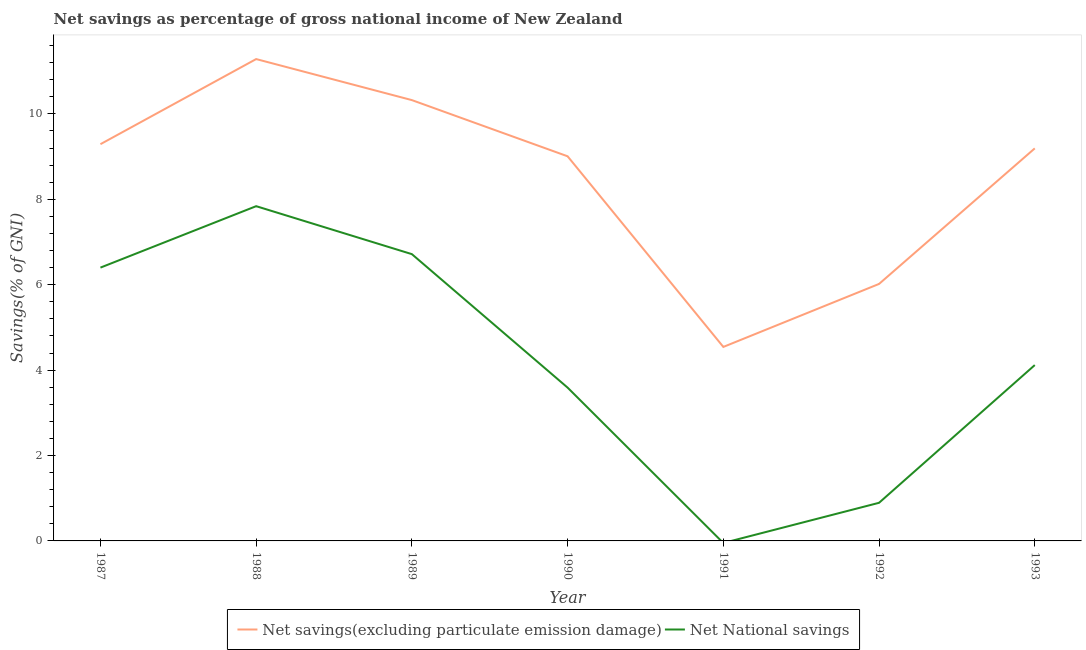Does the line corresponding to net savings(excluding particulate emission damage) intersect with the line corresponding to net national savings?
Your answer should be compact. No. Is the number of lines equal to the number of legend labels?
Keep it short and to the point. No. What is the net national savings in 1990?
Provide a short and direct response. 3.59. Across all years, what is the maximum net national savings?
Keep it short and to the point. 7.84. Across all years, what is the minimum net savings(excluding particulate emission damage)?
Make the answer very short. 4.54. In which year was the net national savings maximum?
Your answer should be very brief. 1988. What is the total net savings(excluding particulate emission damage) in the graph?
Offer a terse response. 59.66. What is the difference between the net national savings in 1987 and that in 1988?
Give a very brief answer. -1.44. What is the difference between the net savings(excluding particulate emission damage) in 1990 and the net national savings in 1992?
Offer a terse response. 8.11. What is the average net savings(excluding particulate emission damage) per year?
Make the answer very short. 8.52. In the year 1990, what is the difference between the net savings(excluding particulate emission damage) and net national savings?
Offer a very short reply. 5.42. What is the ratio of the net national savings in 1987 to that in 1993?
Provide a short and direct response. 1.55. Is the net savings(excluding particulate emission damage) in 1987 less than that in 1990?
Offer a very short reply. No. What is the difference between the highest and the second highest net national savings?
Provide a succinct answer. 1.12. What is the difference between the highest and the lowest net national savings?
Provide a succinct answer. 7.84. In how many years, is the net savings(excluding particulate emission damage) greater than the average net savings(excluding particulate emission damage) taken over all years?
Provide a succinct answer. 5. Is the net savings(excluding particulate emission damage) strictly greater than the net national savings over the years?
Your answer should be very brief. Yes. Is the net national savings strictly less than the net savings(excluding particulate emission damage) over the years?
Provide a succinct answer. Yes. How many lines are there?
Offer a terse response. 2. Where does the legend appear in the graph?
Make the answer very short. Bottom center. How many legend labels are there?
Your answer should be very brief. 2. How are the legend labels stacked?
Your answer should be very brief. Horizontal. What is the title of the graph?
Your answer should be compact. Net savings as percentage of gross national income of New Zealand. Does "Manufacturing industries and construction" appear as one of the legend labels in the graph?
Offer a terse response. No. What is the label or title of the Y-axis?
Keep it short and to the point. Savings(% of GNI). What is the Savings(% of GNI) in Net savings(excluding particulate emission damage) in 1987?
Provide a short and direct response. 9.29. What is the Savings(% of GNI) in Net National savings in 1987?
Your response must be concise. 6.4. What is the Savings(% of GNI) of Net savings(excluding particulate emission damage) in 1988?
Your answer should be compact. 11.28. What is the Savings(% of GNI) of Net National savings in 1988?
Offer a terse response. 7.84. What is the Savings(% of GNI) in Net savings(excluding particulate emission damage) in 1989?
Ensure brevity in your answer.  10.32. What is the Savings(% of GNI) of Net National savings in 1989?
Provide a short and direct response. 6.72. What is the Savings(% of GNI) in Net savings(excluding particulate emission damage) in 1990?
Offer a terse response. 9.01. What is the Savings(% of GNI) in Net National savings in 1990?
Your response must be concise. 3.59. What is the Savings(% of GNI) in Net savings(excluding particulate emission damage) in 1991?
Your response must be concise. 4.54. What is the Savings(% of GNI) in Net savings(excluding particulate emission damage) in 1992?
Your answer should be compact. 6.02. What is the Savings(% of GNI) of Net National savings in 1992?
Your response must be concise. 0.89. What is the Savings(% of GNI) in Net savings(excluding particulate emission damage) in 1993?
Offer a very short reply. 9.19. What is the Savings(% of GNI) in Net National savings in 1993?
Your response must be concise. 4.12. Across all years, what is the maximum Savings(% of GNI) in Net savings(excluding particulate emission damage)?
Your answer should be very brief. 11.28. Across all years, what is the maximum Savings(% of GNI) of Net National savings?
Make the answer very short. 7.84. Across all years, what is the minimum Savings(% of GNI) of Net savings(excluding particulate emission damage)?
Provide a short and direct response. 4.54. Across all years, what is the minimum Savings(% of GNI) in Net National savings?
Make the answer very short. 0. What is the total Savings(% of GNI) in Net savings(excluding particulate emission damage) in the graph?
Give a very brief answer. 59.66. What is the total Savings(% of GNI) of Net National savings in the graph?
Make the answer very short. 29.56. What is the difference between the Savings(% of GNI) in Net savings(excluding particulate emission damage) in 1987 and that in 1988?
Give a very brief answer. -1.99. What is the difference between the Savings(% of GNI) of Net National savings in 1987 and that in 1988?
Your response must be concise. -1.44. What is the difference between the Savings(% of GNI) in Net savings(excluding particulate emission damage) in 1987 and that in 1989?
Give a very brief answer. -1.03. What is the difference between the Savings(% of GNI) of Net National savings in 1987 and that in 1989?
Provide a succinct answer. -0.32. What is the difference between the Savings(% of GNI) of Net savings(excluding particulate emission damage) in 1987 and that in 1990?
Give a very brief answer. 0.28. What is the difference between the Savings(% of GNI) of Net National savings in 1987 and that in 1990?
Offer a terse response. 2.81. What is the difference between the Savings(% of GNI) in Net savings(excluding particulate emission damage) in 1987 and that in 1991?
Ensure brevity in your answer.  4.75. What is the difference between the Savings(% of GNI) of Net savings(excluding particulate emission damage) in 1987 and that in 1992?
Offer a terse response. 3.27. What is the difference between the Savings(% of GNI) of Net National savings in 1987 and that in 1992?
Your response must be concise. 5.51. What is the difference between the Savings(% of GNI) of Net savings(excluding particulate emission damage) in 1987 and that in 1993?
Offer a terse response. 0.1. What is the difference between the Savings(% of GNI) of Net National savings in 1987 and that in 1993?
Provide a succinct answer. 2.28. What is the difference between the Savings(% of GNI) of Net savings(excluding particulate emission damage) in 1988 and that in 1989?
Ensure brevity in your answer.  0.96. What is the difference between the Savings(% of GNI) of Net National savings in 1988 and that in 1989?
Offer a very short reply. 1.12. What is the difference between the Savings(% of GNI) of Net savings(excluding particulate emission damage) in 1988 and that in 1990?
Your answer should be very brief. 2.28. What is the difference between the Savings(% of GNI) of Net National savings in 1988 and that in 1990?
Offer a very short reply. 4.25. What is the difference between the Savings(% of GNI) of Net savings(excluding particulate emission damage) in 1988 and that in 1991?
Keep it short and to the point. 6.74. What is the difference between the Savings(% of GNI) of Net savings(excluding particulate emission damage) in 1988 and that in 1992?
Your response must be concise. 5.27. What is the difference between the Savings(% of GNI) in Net National savings in 1988 and that in 1992?
Give a very brief answer. 6.95. What is the difference between the Savings(% of GNI) in Net savings(excluding particulate emission damage) in 1988 and that in 1993?
Offer a very short reply. 2.09. What is the difference between the Savings(% of GNI) of Net National savings in 1988 and that in 1993?
Your answer should be very brief. 3.72. What is the difference between the Savings(% of GNI) in Net savings(excluding particulate emission damage) in 1989 and that in 1990?
Your answer should be compact. 1.32. What is the difference between the Savings(% of GNI) in Net National savings in 1989 and that in 1990?
Offer a terse response. 3.13. What is the difference between the Savings(% of GNI) in Net savings(excluding particulate emission damage) in 1989 and that in 1991?
Offer a terse response. 5.78. What is the difference between the Savings(% of GNI) of Net savings(excluding particulate emission damage) in 1989 and that in 1992?
Your response must be concise. 4.3. What is the difference between the Savings(% of GNI) of Net National savings in 1989 and that in 1992?
Ensure brevity in your answer.  5.82. What is the difference between the Savings(% of GNI) of Net savings(excluding particulate emission damage) in 1989 and that in 1993?
Offer a very short reply. 1.13. What is the difference between the Savings(% of GNI) of Net National savings in 1989 and that in 1993?
Keep it short and to the point. 2.6. What is the difference between the Savings(% of GNI) in Net savings(excluding particulate emission damage) in 1990 and that in 1991?
Provide a succinct answer. 4.46. What is the difference between the Savings(% of GNI) of Net savings(excluding particulate emission damage) in 1990 and that in 1992?
Provide a succinct answer. 2.99. What is the difference between the Savings(% of GNI) of Net National savings in 1990 and that in 1992?
Make the answer very short. 2.7. What is the difference between the Savings(% of GNI) in Net savings(excluding particulate emission damage) in 1990 and that in 1993?
Make the answer very short. -0.19. What is the difference between the Savings(% of GNI) in Net National savings in 1990 and that in 1993?
Ensure brevity in your answer.  -0.53. What is the difference between the Savings(% of GNI) of Net savings(excluding particulate emission damage) in 1991 and that in 1992?
Make the answer very short. -1.48. What is the difference between the Savings(% of GNI) in Net savings(excluding particulate emission damage) in 1991 and that in 1993?
Provide a succinct answer. -4.65. What is the difference between the Savings(% of GNI) in Net savings(excluding particulate emission damage) in 1992 and that in 1993?
Your answer should be very brief. -3.17. What is the difference between the Savings(% of GNI) in Net National savings in 1992 and that in 1993?
Make the answer very short. -3.23. What is the difference between the Savings(% of GNI) of Net savings(excluding particulate emission damage) in 1987 and the Savings(% of GNI) of Net National savings in 1988?
Your response must be concise. 1.45. What is the difference between the Savings(% of GNI) in Net savings(excluding particulate emission damage) in 1987 and the Savings(% of GNI) in Net National savings in 1989?
Make the answer very short. 2.58. What is the difference between the Savings(% of GNI) in Net savings(excluding particulate emission damage) in 1987 and the Savings(% of GNI) in Net National savings in 1990?
Ensure brevity in your answer.  5.7. What is the difference between the Savings(% of GNI) in Net savings(excluding particulate emission damage) in 1987 and the Savings(% of GNI) in Net National savings in 1992?
Your answer should be compact. 8.4. What is the difference between the Savings(% of GNI) of Net savings(excluding particulate emission damage) in 1987 and the Savings(% of GNI) of Net National savings in 1993?
Give a very brief answer. 5.17. What is the difference between the Savings(% of GNI) in Net savings(excluding particulate emission damage) in 1988 and the Savings(% of GNI) in Net National savings in 1989?
Make the answer very short. 4.57. What is the difference between the Savings(% of GNI) of Net savings(excluding particulate emission damage) in 1988 and the Savings(% of GNI) of Net National savings in 1990?
Your response must be concise. 7.69. What is the difference between the Savings(% of GNI) in Net savings(excluding particulate emission damage) in 1988 and the Savings(% of GNI) in Net National savings in 1992?
Keep it short and to the point. 10.39. What is the difference between the Savings(% of GNI) in Net savings(excluding particulate emission damage) in 1988 and the Savings(% of GNI) in Net National savings in 1993?
Provide a succinct answer. 7.17. What is the difference between the Savings(% of GNI) of Net savings(excluding particulate emission damage) in 1989 and the Savings(% of GNI) of Net National savings in 1990?
Offer a very short reply. 6.73. What is the difference between the Savings(% of GNI) in Net savings(excluding particulate emission damage) in 1989 and the Savings(% of GNI) in Net National savings in 1992?
Your answer should be very brief. 9.43. What is the difference between the Savings(% of GNI) of Net savings(excluding particulate emission damage) in 1989 and the Savings(% of GNI) of Net National savings in 1993?
Provide a short and direct response. 6.21. What is the difference between the Savings(% of GNI) of Net savings(excluding particulate emission damage) in 1990 and the Savings(% of GNI) of Net National savings in 1992?
Keep it short and to the point. 8.11. What is the difference between the Savings(% of GNI) in Net savings(excluding particulate emission damage) in 1990 and the Savings(% of GNI) in Net National savings in 1993?
Provide a succinct answer. 4.89. What is the difference between the Savings(% of GNI) in Net savings(excluding particulate emission damage) in 1991 and the Savings(% of GNI) in Net National savings in 1992?
Offer a very short reply. 3.65. What is the difference between the Savings(% of GNI) in Net savings(excluding particulate emission damage) in 1991 and the Savings(% of GNI) in Net National savings in 1993?
Your response must be concise. 0.42. What is the difference between the Savings(% of GNI) of Net savings(excluding particulate emission damage) in 1992 and the Savings(% of GNI) of Net National savings in 1993?
Ensure brevity in your answer.  1.9. What is the average Savings(% of GNI) in Net savings(excluding particulate emission damage) per year?
Offer a very short reply. 8.52. What is the average Savings(% of GNI) of Net National savings per year?
Offer a terse response. 4.22. In the year 1987, what is the difference between the Savings(% of GNI) in Net savings(excluding particulate emission damage) and Savings(% of GNI) in Net National savings?
Your answer should be compact. 2.89. In the year 1988, what is the difference between the Savings(% of GNI) of Net savings(excluding particulate emission damage) and Savings(% of GNI) of Net National savings?
Provide a short and direct response. 3.45. In the year 1989, what is the difference between the Savings(% of GNI) in Net savings(excluding particulate emission damage) and Savings(% of GNI) in Net National savings?
Ensure brevity in your answer.  3.61. In the year 1990, what is the difference between the Savings(% of GNI) of Net savings(excluding particulate emission damage) and Savings(% of GNI) of Net National savings?
Your response must be concise. 5.42. In the year 1992, what is the difference between the Savings(% of GNI) of Net savings(excluding particulate emission damage) and Savings(% of GNI) of Net National savings?
Provide a succinct answer. 5.13. In the year 1993, what is the difference between the Savings(% of GNI) in Net savings(excluding particulate emission damage) and Savings(% of GNI) in Net National savings?
Your response must be concise. 5.08. What is the ratio of the Savings(% of GNI) in Net savings(excluding particulate emission damage) in 1987 to that in 1988?
Your answer should be very brief. 0.82. What is the ratio of the Savings(% of GNI) of Net National savings in 1987 to that in 1988?
Your answer should be very brief. 0.82. What is the ratio of the Savings(% of GNI) in Net savings(excluding particulate emission damage) in 1987 to that in 1989?
Provide a succinct answer. 0.9. What is the ratio of the Savings(% of GNI) in Net National savings in 1987 to that in 1989?
Provide a short and direct response. 0.95. What is the ratio of the Savings(% of GNI) of Net savings(excluding particulate emission damage) in 1987 to that in 1990?
Give a very brief answer. 1.03. What is the ratio of the Savings(% of GNI) of Net National savings in 1987 to that in 1990?
Your response must be concise. 1.78. What is the ratio of the Savings(% of GNI) of Net savings(excluding particulate emission damage) in 1987 to that in 1991?
Make the answer very short. 2.05. What is the ratio of the Savings(% of GNI) of Net savings(excluding particulate emission damage) in 1987 to that in 1992?
Ensure brevity in your answer.  1.54. What is the ratio of the Savings(% of GNI) in Net National savings in 1987 to that in 1992?
Offer a terse response. 7.17. What is the ratio of the Savings(% of GNI) of Net savings(excluding particulate emission damage) in 1987 to that in 1993?
Make the answer very short. 1.01. What is the ratio of the Savings(% of GNI) of Net National savings in 1987 to that in 1993?
Offer a terse response. 1.55. What is the ratio of the Savings(% of GNI) in Net savings(excluding particulate emission damage) in 1988 to that in 1989?
Give a very brief answer. 1.09. What is the ratio of the Savings(% of GNI) of Net National savings in 1988 to that in 1989?
Keep it short and to the point. 1.17. What is the ratio of the Savings(% of GNI) of Net savings(excluding particulate emission damage) in 1988 to that in 1990?
Your answer should be compact. 1.25. What is the ratio of the Savings(% of GNI) in Net National savings in 1988 to that in 1990?
Give a very brief answer. 2.18. What is the ratio of the Savings(% of GNI) of Net savings(excluding particulate emission damage) in 1988 to that in 1991?
Provide a succinct answer. 2.48. What is the ratio of the Savings(% of GNI) in Net savings(excluding particulate emission damage) in 1988 to that in 1992?
Provide a succinct answer. 1.88. What is the ratio of the Savings(% of GNI) in Net National savings in 1988 to that in 1992?
Provide a succinct answer. 8.78. What is the ratio of the Savings(% of GNI) of Net savings(excluding particulate emission damage) in 1988 to that in 1993?
Your response must be concise. 1.23. What is the ratio of the Savings(% of GNI) of Net National savings in 1988 to that in 1993?
Offer a very short reply. 1.9. What is the ratio of the Savings(% of GNI) in Net savings(excluding particulate emission damage) in 1989 to that in 1990?
Your response must be concise. 1.15. What is the ratio of the Savings(% of GNI) of Net National savings in 1989 to that in 1990?
Ensure brevity in your answer.  1.87. What is the ratio of the Savings(% of GNI) in Net savings(excluding particulate emission damage) in 1989 to that in 1991?
Give a very brief answer. 2.27. What is the ratio of the Savings(% of GNI) in Net savings(excluding particulate emission damage) in 1989 to that in 1992?
Your answer should be very brief. 1.72. What is the ratio of the Savings(% of GNI) in Net National savings in 1989 to that in 1992?
Provide a short and direct response. 7.52. What is the ratio of the Savings(% of GNI) in Net savings(excluding particulate emission damage) in 1989 to that in 1993?
Offer a terse response. 1.12. What is the ratio of the Savings(% of GNI) in Net National savings in 1989 to that in 1993?
Your answer should be very brief. 1.63. What is the ratio of the Savings(% of GNI) in Net savings(excluding particulate emission damage) in 1990 to that in 1991?
Provide a succinct answer. 1.98. What is the ratio of the Savings(% of GNI) in Net savings(excluding particulate emission damage) in 1990 to that in 1992?
Give a very brief answer. 1.5. What is the ratio of the Savings(% of GNI) in Net National savings in 1990 to that in 1992?
Give a very brief answer. 4.02. What is the ratio of the Savings(% of GNI) of Net savings(excluding particulate emission damage) in 1990 to that in 1993?
Offer a terse response. 0.98. What is the ratio of the Savings(% of GNI) of Net National savings in 1990 to that in 1993?
Your response must be concise. 0.87. What is the ratio of the Savings(% of GNI) in Net savings(excluding particulate emission damage) in 1991 to that in 1992?
Your response must be concise. 0.75. What is the ratio of the Savings(% of GNI) in Net savings(excluding particulate emission damage) in 1991 to that in 1993?
Keep it short and to the point. 0.49. What is the ratio of the Savings(% of GNI) in Net savings(excluding particulate emission damage) in 1992 to that in 1993?
Your response must be concise. 0.65. What is the ratio of the Savings(% of GNI) in Net National savings in 1992 to that in 1993?
Keep it short and to the point. 0.22. What is the difference between the highest and the second highest Savings(% of GNI) of Net savings(excluding particulate emission damage)?
Offer a very short reply. 0.96. What is the difference between the highest and the second highest Savings(% of GNI) in Net National savings?
Your answer should be very brief. 1.12. What is the difference between the highest and the lowest Savings(% of GNI) in Net savings(excluding particulate emission damage)?
Offer a very short reply. 6.74. What is the difference between the highest and the lowest Savings(% of GNI) of Net National savings?
Provide a short and direct response. 7.84. 